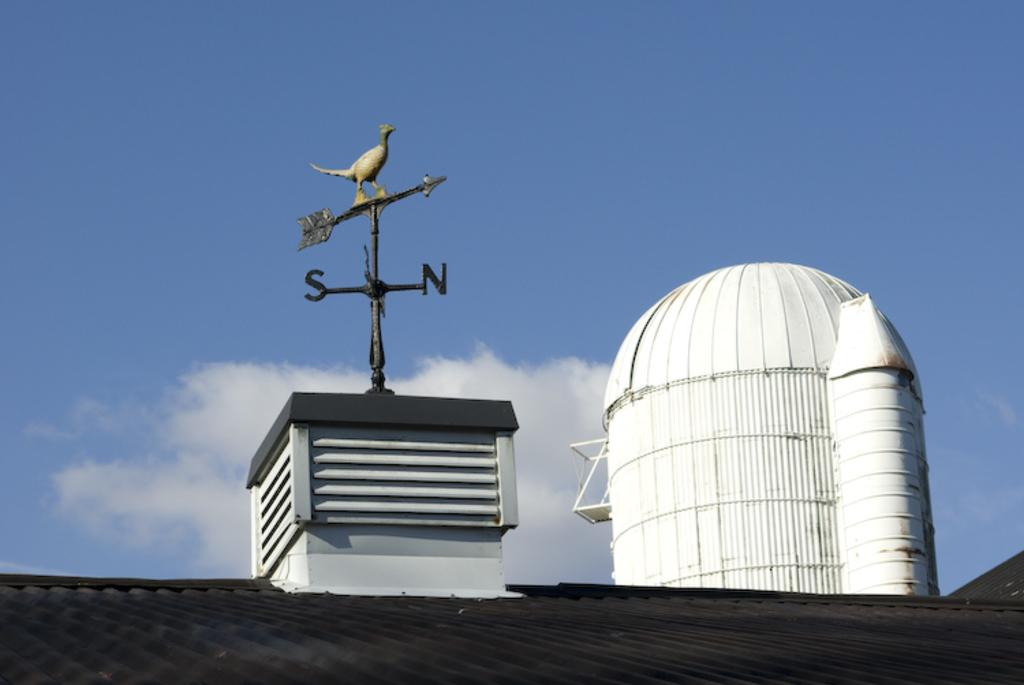What is located at the bottom of the image? There is a roof at the bottom of the image. What can be found in the center of the image? There is a box and poles in the center of the image, as well as a statue. What is on the right side of the image? There is a building on the right side of the image. What is visible at the top of the image? The sky is visible at the top of the image. Are there any icicles hanging from the roof in the image? There is no mention of icicles in the provided facts, so we cannot determine if any are present in the image. What type of pump is used to extract oil from the ground in the image? There is no mention of a pump or oil extraction in the provided facts, so we cannot determine if any are present in the image. 